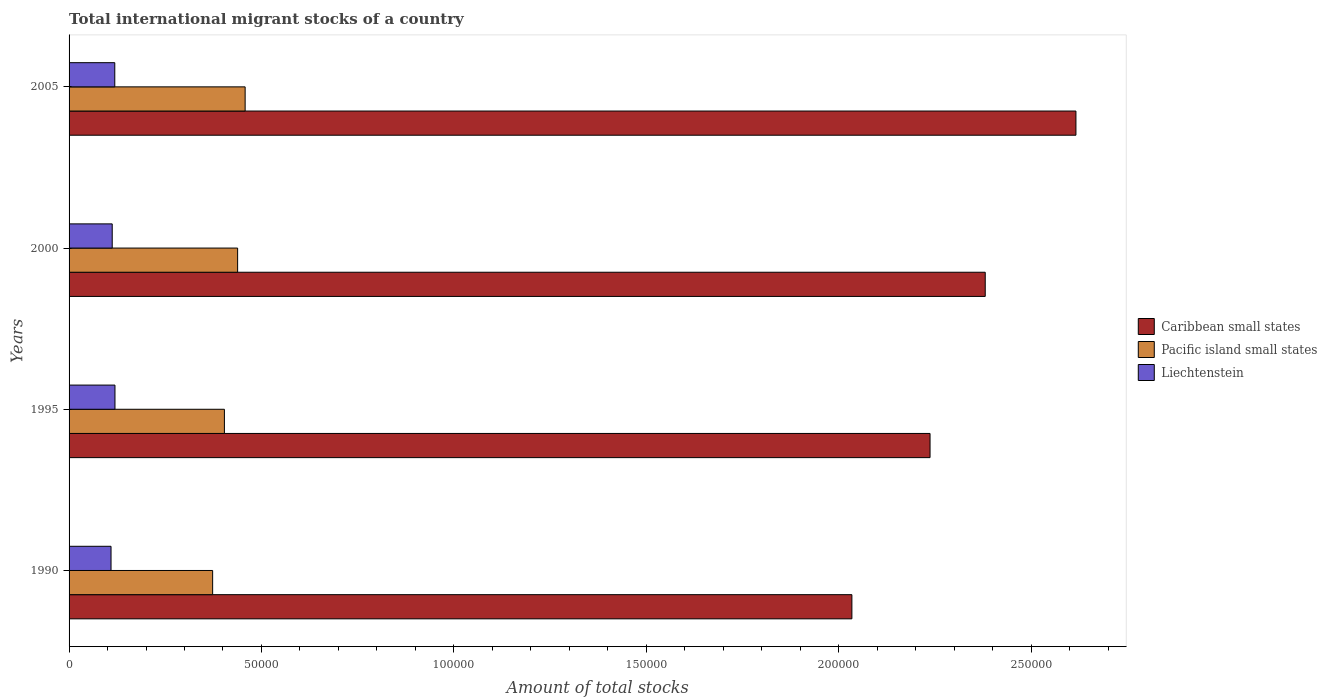How many different coloured bars are there?
Your response must be concise. 3. How many groups of bars are there?
Your answer should be compact. 4. Are the number of bars per tick equal to the number of legend labels?
Give a very brief answer. Yes. Are the number of bars on each tick of the Y-axis equal?
Offer a terse response. Yes. How many bars are there on the 4th tick from the top?
Offer a very short reply. 3. In how many cases, is the number of bars for a given year not equal to the number of legend labels?
Offer a very short reply. 0. What is the amount of total stocks in in Caribbean small states in 1995?
Ensure brevity in your answer.  2.24e+05. Across all years, what is the maximum amount of total stocks in in Caribbean small states?
Offer a very short reply. 2.62e+05. Across all years, what is the minimum amount of total stocks in in Pacific island small states?
Give a very brief answer. 3.73e+04. What is the total amount of total stocks in in Caribbean small states in the graph?
Offer a terse response. 9.27e+05. What is the difference between the amount of total stocks in in Caribbean small states in 2000 and that in 2005?
Provide a succinct answer. -2.36e+04. What is the difference between the amount of total stocks in in Caribbean small states in 2005 and the amount of total stocks in in Liechtenstein in 1995?
Make the answer very short. 2.50e+05. What is the average amount of total stocks in in Pacific island small states per year?
Make the answer very short. 4.18e+04. In the year 2000, what is the difference between the amount of total stocks in in Liechtenstein and amount of total stocks in in Pacific island small states?
Your answer should be compact. -3.26e+04. In how many years, is the amount of total stocks in in Caribbean small states greater than 190000 ?
Offer a very short reply. 4. What is the ratio of the amount of total stocks in in Caribbean small states in 1990 to that in 1995?
Keep it short and to the point. 0.91. Is the difference between the amount of total stocks in in Liechtenstein in 1995 and 2000 greater than the difference between the amount of total stocks in in Pacific island small states in 1995 and 2000?
Make the answer very short. Yes. What is the difference between the highest and the second highest amount of total stocks in in Pacific island small states?
Your response must be concise. 1950. What is the difference between the highest and the lowest amount of total stocks in in Liechtenstein?
Offer a terse response. 1021. In how many years, is the amount of total stocks in in Caribbean small states greater than the average amount of total stocks in in Caribbean small states taken over all years?
Give a very brief answer. 2. What does the 3rd bar from the top in 2005 represents?
Provide a succinct answer. Caribbean small states. What does the 2nd bar from the bottom in 2005 represents?
Keep it short and to the point. Pacific island small states. Is it the case that in every year, the sum of the amount of total stocks in in Pacific island small states and amount of total stocks in in Caribbean small states is greater than the amount of total stocks in in Liechtenstein?
Make the answer very short. Yes. How many bars are there?
Your response must be concise. 12. How many years are there in the graph?
Make the answer very short. 4. Are the values on the major ticks of X-axis written in scientific E-notation?
Provide a short and direct response. No. Does the graph contain grids?
Give a very brief answer. No. How many legend labels are there?
Keep it short and to the point. 3. What is the title of the graph?
Give a very brief answer. Total international migrant stocks of a country. What is the label or title of the X-axis?
Ensure brevity in your answer.  Amount of total stocks. What is the label or title of the Y-axis?
Your response must be concise. Years. What is the Amount of total stocks of Caribbean small states in 1990?
Your answer should be very brief. 2.03e+05. What is the Amount of total stocks of Pacific island small states in 1990?
Give a very brief answer. 3.73e+04. What is the Amount of total stocks in Liechtenstein in 1990?
Offer a very short reply. 1.09e+04. What is the Amount of total stocks in Caribbean small states in 1995?
Provide a succinct answer. 2.24e+05. What is the Amount of total stocks of Pacific island small states in 1995?
Your answer should be very brief. 4.04e+04. What is the Amount of total stocks of Liechtenstein in 1995?
Your answer should be compact. 1.19e+04. What is the Amount of total stocks of Caribbean small states in 2000?
Offer a terse response. 2.38e+05. What is the Amount of total stocks in Pacific island small states in 2000?
Offer a very short reply. 4.38e+04. What is the Amount of total stocks of Liechtenstein in 2000?
Ensure brevity in your answer.  1.12e+04. What is the Amount of total stocks in Caribbean small states in 2005?
Your answer should be very brief. 2.62e+05. What is the Amount of total stocks in Pacific island small states in 2005?
Provide a succinct answer. 4.58e+04. What is the Amount of total stocks in Liechtenstein in 2005?
Keep it short and to the point. 1.19e+04. Across all years, what is the maximum Amount of total stocks of Caribbean small states?
Your response must be concise. 2.62e+05. Across all years, what is the maximum Amount of total stocks in Pacific island small states?
Make the answer very short. 4.58e+04. Across all years, what is the maximum Amount of total stocks in Liechtenstein?
Keep it short and to the point. 1.19e+04. Across all years, what is the minimum Amount of total stocks of Caribbean small states?
Provide a short and direct response. 2.03e+05. Across all years, what is the minimum Amount of total stocks of Pacific island small states?
Offer a terse response. 3.73e+04. Across all years, what is the minimum Amount of total stocks of Liechtenstein?
Your answer should be compact. 1.09e+04. What is the total Amount of total stocks in Caribbean small states in the graph?
Keep it short and to the point. 9.27e+05. What is the total Amount of total stocks in Pacific island small states in the graph?
Provide a succinct answer. 1.67e+05. What is the total Amount of total stocks in Liechtenstein in the graph?
Your answer should be very brief. 4.59e+04. What is the difference between the Amount of total stocks of Caribbean small states in 1990 and that in 1995?
Ensure brevity in your answer.  -2.03e+04. What is the difference between the Amount of total stocks in Pacific island small states in 1990 and that in 1995?
Provide a succinct answer. -3058. What is the difference between the Amount of total stocks in Liechtenstein in 1990 and that in 1995?
Your answer should be very brief. -1021. What is the difference between the Amount of total stocks in Caribbean small states in 1990 and that in 2000?
Your answer should be compact. -3.47e+04. What is the difference between the Amount of total stocks in Pacific island small states in 1990 and that in 2000?
Give a very brief answer. -6496. What is the difference between the Amount of total stocks in Liechtenstein in 1990 and that in 2000?
Your answer should be very brief. -309. What is the difference between the Amount of total stocks in Caribbean small states in 1990 and that in 2005?
Provide a short and direct response. -5.82e+04. What is the difference between the Amount of total stocks in Pacific island small states in 1990 and that in 2005?
Your response must be concise. -8446. What is the difference between the Amount of total stocks of Liechtenstein in 1990 and that in 2005?
Keep it short and to the point. -975. What is the difference between the Amount of total stocks of Caribbean small states in 1995 and that in 2000?
Your answer should be very brief. -1.43e+04. What is the difference between the Amount of total stocks in Pacific island small states in 1995 and that in 2000?
Your response must be concise. -3438. What is the difference between the Amount of total stocks of Liechtenstein in 1995 and that in 2000?
Offer a very short reply. 712. What is the difference between the Amount of total stocks of Caribbean small states in 1995 and that in 2005?
Ensure brevity in your answer.  -3.79e+04. What is the difference between the Amount of total stocks of Pacific island small states in 1995 and that in 2005?
Keep it short and to the point. -5388. What is the difference between the Amount of total stocks of Liechtenstein in 1995 and that in 2005?
Offer a very short reply. 46. What is the difference between the Amount of total stocks in Caribbean small states in 2000 and that in 2005?
Your response must be concise. -2.36e+04. What is the difference between the Amount of total stocks in Pacific island small states in 2000 and that in 2005?
Ensure brevity in your answer.  -1950. What is the difference between the Amount of total stocks of Liechtenstein in 2000 and that in 2005?
Provide a short and direct response. -666. What is the difference between the Amount of total stocks in Caribbean small states in 1990 and the Amount of total stocks in Pacific island small states in 1995?
Offer a terse response. 1.63e+05. What is the difference between the Amount of total stocks of Caribbean small states in 1990 and the Amount of total stocks of Liechtenstein in 1995?
Your response must be concise. 1.92e+05. What is the difference between the Amount of total stocks in Pacific island small states in 1990 and the Amount of total stocks in Liechtenstein in 1995?
Offer a terse response. 2.54e+04. What is the difference between the Amount of total stocks of Caribbean small states in 1990 and the Amount of total stocks of Pacific island small states in 2000?
Keep it short and to the point. 1.60e+05. What is the difference between the Amount of total stocks in Caribbean small states in 1990 and the Amount of total stocks in Liechtenstein in 2000?
Offer a terse response. 1.92e+05. What is the difference between the Amount of total stocks in Pacific island small states in 1990 and the Amount of total stocks in Liechtenstein in 2000?
Provide a short and direct response. 2.61e+04. What is the difference between the Amount of total stocks of Caribbean small states in 1990 and the Amount of total stocks of Pacific island small states in 2005?
Make the answer very short. 1.58e+05. What is the difference between the Amount of total stocks in Caribbean small states in 1990 and the Amount of total stocks in Liechtenstein in 2005?
Offer a very short reply. 1.92e+05. What is the difference between the Amount of total stocks in Pacific island small states in 1990 and the Amount of total stocks in Liechtenstein in 2005?
Provide a short and direct response. 2.54e+04. What is the difference between the Amount of total stocks in Caribbean small states in 1995 and the Amount of total stocks in Pacific island small states in 2000?
Make the answer very short. 1.80e+05. What is the difference between the Amount of total stocks in Caribbean small states in 1995 and the Amount of total stocks in Liechtenstein in 2000?
Provide a succinct answer. 2.13e+05. What is the difference between the Amount of total stocks of Pacific island small states in 1995 and the Amount of total stocks of Liechtenstein in 2000?
Provide a succinct answer. 2.92e+04. What is the difference between the Amount of total stocks of Caribbean small states in 1995 and the Amount of total stocks of Pacific island small states in 2005?
Keep it short and to the point. 1.78e+05. What is the difference between the Amount of total stocks of Caribbean small states in 1995 and the Amount of total stocks of Liechtenstein in 2005?
Your answer should be compact. 2.12e+05. What is the difference between the Amount of total stocks in Pacific island small states in 1995 and the Amount of total stocks in Liechtenstein in 2005?
Keep it short and to the point. 2.85e+04. What is the difference between the Amount of total stocks in Caribbean small states in 2000 and the Amount of total stocks in Pacific island small states in 2005?
Provide a short and direct response. 1.92e+05. What is the difference between the Amount of total stocks of Caribbean small states in 2000 and the Amount of total stocks of Liechtenstein in 2005?
Your answer should be very brief. 2.26e+05. What is the difference between the Amount of total stocks of Pacific island small states in 2000 and the Amount of total stocks of Liechtenstein in 2005?
Your response must be concise. 3.19e+04. What is the average Amount of total stocks in Caribbean small states per year?
Your response must be concise. 2.32e+05. What is the average Amount of total stocks of Pacific island small states per year?
Provide a succinct answer. 4.18e+04. What is the average Amount of total stocks of Liechtenstein per year?
Ensure brevity in your answer.  1.15e+04. In the year 1990, what is the difference between the Amount of total stocks in Caribbean small states and Amount of total stocks in Pacific island small states?
Ensure brevity in your answer.  1.66e+05. In the year 1990, what is the difference between the Amount of total stocks of Caribbean small states and Amount of total stocks of Liechtenstein?
Give a very brief answer. 1.93e+05. In the year 1990, what is the difference between the Amount of total stocks in Pacific island small states and Amount of total stocks in Liechtenstein?
Offer a terse response. 2.64e+04. In the year 1995, what is the difference between the Amount of total stocks in Caribbean small states and Amount of total stocks in Pacific island small states?
Keep it short and to the point. 1.83e+05. In the year 1995, what is the difference between the Amount of total stocks in Caribbean small states and Amount of total stocks in Liechtenstein?
Make the answer very short. 2.12e+05. In the year 1995, what is the difference between the Amount of total stocks of Pacific island small states and Amount of total stocks of Liechtenstein?
Provide a succinct answer. 2.84e+04. In the year 2000, what is the difference between the Amount of total stocks of Caribbean small states and Amount of total stocks of Pacific island small states?
Your answer should be very brief. 1.94e+05. In the year 2000, what is the difference between the Amount of total stocks of Caribbean small states and Amount of total stocks of Liechtenstein?
Your answer should be very brief. 2.27e+05. In the year 2000, what is the difference between the Amount of total stocks of Pacific island small states and Amount of total stocks of Liechtenstein?
Ensure brevity in your answer.  3.26e+04. In the year 2005, what is the difference between the Amount of total stocks in Caribbean small states and Amount of total stocks in Pacific island small states?
Give a very brief answer. 2.16e+05. In the year 2005, what is the difference between the Amount of total stocks of Caribbean small states and Amount of total stocks of Liechtenstein?
Ensure brevity in your answer.  2.50e+05. In the year 2005, what is the difference between the Amount of total stocks of Pacific island small states and Amount of total stocks of Liechtenstein?
Provide a short and direct response. 3.39e+04. What is the ratio of the Amount of total stocks of Caribbean small states in 1990 to that in 1995?
Your answer should be compact. 0.91. What is the ratio of the Amount of total stocks in Pacific island small states in 1990 to that in 1995?
Give a very brief answer. 0.92. What is the ratio of the Amount of total stocks in Liechtenstein in 1990 to that in 1995?
Keep it short and to the point. 0.91. What is the ratio of the Amount of total stocks of Caribbean small states in 1990 to that in 2000?
Provide a succinct answer. 0.85. What is the ratio of the Amount of total stocks of Pacific island small states in 1990 to that in 2000?
Your response must be concise. 0.85. What is the ratio of the Amount of total stocks in Liechtenstein in 1990 to that in 2000?
Make the answer very short. 0.97. What is the ratio of the Amount of total stocks of Caribbean small states in 1990 to that in 2005?
Your answer should be compact. 0.78. What is the ratio of the Amount of total stocks in Pacific island small states in 1990 to that in 2005?
Offer a terse response. 0.82. What is the ratio of the Amount of total stocks of Liechtenstein in 1990 to that in 2005?
Provide a short and direct response. 0.92. What is the ratio of the Amount of total stocks of Caribbean small states in 1995 to that in 2000?
Your answer should be compact. 0.94. What is the ratio of the Amount of total stocks in Pacific island small states in 1995 to that in 2000?
Your response must be concise. 0.92. What is the ratio of the Amount of total stocks in Liechtenstein in 1995 to that in 2000?
Make the answer very short. 1.06. What is the ratio of the Amount of total stocks of Caribbean small states in 1995 to that in 2005?
Provide a short and direct response. 0.86. What is the ratio of the Amount of total stocks of Pacific island small states in 1995 to that in 2005?
Your answer should be very brief. 0.88. What is the ratio of the Amount of total stocks in Caribbean small states in 2000 to that in 2005?
Give a very brief answer. 0.91. What is the ratio of the Amount of total stocks in Pacific island small states in 2000 to that in 2005?
Your answer should be very brief. 0.96. What is the ratio of the Amount of total stocks in Liechtenstein in 2000 to that in 2005?
Your answer should be very brief. 0.94. What is the difference between the highest and the second highest Amount of total stocks in Caribbean small states?
Your response must be concise. 2.36e+04. What is the difference between the highest and the second highest Amount of total stocks in Pacific island small states?
Keep it short and to the point. 1950. What is the difference between the highest and the second highest Amount of total stocks in Liechtenstein?
Make the answer very short. 46. What is the difference between the highest and the lowest Amount of total stocks in Caribbean small states?
Offer a very short reply. 5.82e+04. What is the difference between the highest and the lowest Amount of total stocks in Pacific island small states?
Offer a very short reply. 8446. What is the difference between the highest and the lowest Amount of total stocks in Liechtenstein?
Provide a succinct answer. 1021. 